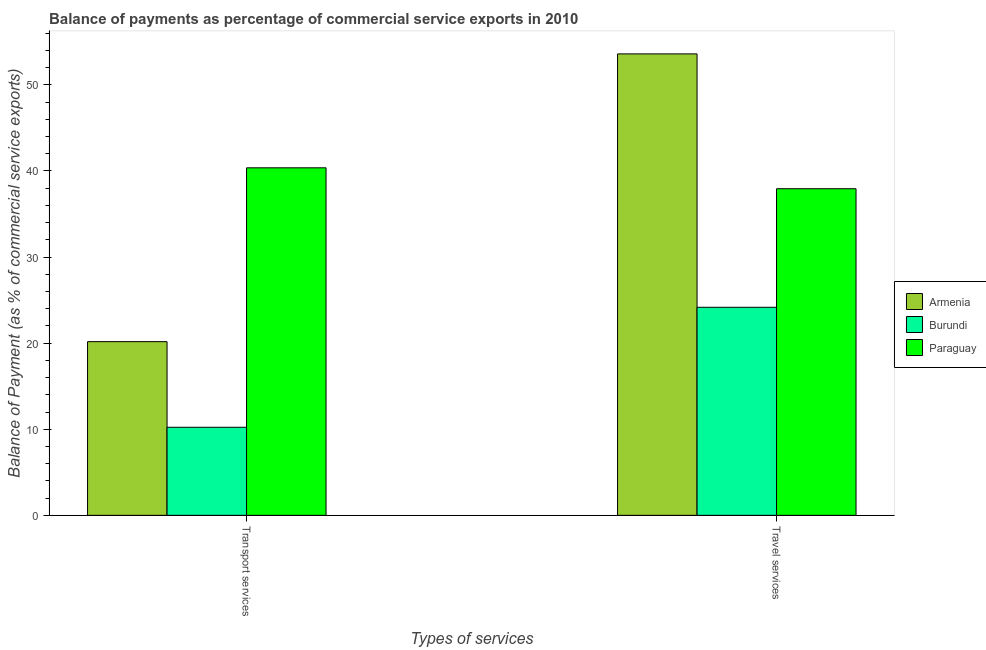How many groups of bars are there?
Your answer should be compact. 2. Are the number of bars per tick equal to the number of legend labels?
Give a very brief answer. Yes. What is the label of the 1st group of bars from the left?
Offer a terse response. Transport services. What is the balance of payments of travel services in Burundi?
Make the answer very short. 24.16. Across all countries, what is the maximum balance of payments of travel services?
Give a very brief answer. 53.59. Across all countries, what is the minimum balance of payments of travel services?
Give a very brief answer. 24.16. In which country was the balance of payments of transport services maximum?
Keep it short and to the point. Paraguay. In which country was the balance of payments of transport services minimum?
Your response must be concise. Burundi. What is the total balance of payments of travel services in the graph?
Offer a terse response. 115.68. What is the difference between the balance of payments of travel services in Paraguay and that in Armenia?
Your answer should be compact. -15.66. What is the difference between the balance of payments of travel services in Armenia and the balance of payments of transport services in Burundi?
Offer a terse response. 43.36. What is the average balance of payments of transport services per country?
Ensure brevity in your answer.  23.58. What is the difference between the balance of payments of travel services and balance of payments of transport services in Paraguay?
Provide a succinct answer. -2.43. What is the ratio of the balance of payments of transport services in Burundi to that in Armenia?
Your answer should be compact. 0.51. In how many countries, is the balance of payments of transport services greater than the average balance of payments of transport services taken over all countries?
Your response must be concise. 1. What does the 2nd bar from the left in Transport services represents?
Offer a very short reply. Burundi. What does the 1st bar from the right in Travel services represents?
Provide a succinct answer. Paraguay. Are all the bars in the graph horizontal?
Ensure brevity in your answer.  No. How many countries are there in the graph?
Keep it short and to the point. 3. Does the graph contain any zero values?
Keep it short and to the point. No. How many legend labels are there?
Offer a terse response. 3. What is the title of the graph?
Give a very brief answer. Balance of payments as percentage of commercial service exports in 2010. Does "Mongolia" appear as one of the legend labels in the graph?
Offer a terse response. No. What is the label or title of the X-axis?
Keep it short and to the point. Types of services. What is the label or title of the Y-axis?
Provide a succinct answer. Balance of Payment (as % of commercial service exports). What is the Balance of Payment (as % of commercial service exports) in Armenia in Transport services?
Ensure brevity in your answer.  20.17. What is the Balance of Payment (as % of commercial service exports) of Burundi in Transport services?
Keep it short and to the point. 10.23. What is the Balance of Payment (as % of commercial service exports) of Paraguay in Transport services?
Your answer should be compact. 40.36. What is the Balance of Payment (as % of commercial service exports) in Armenia in Travel services?
Ensure brevity in your answer.  53.59. What is the Balance of Payment (as % of commercial service exports) of Burundi in Travel services?
Keep it short and to the point. 24.16. What is the Balance of Payment (as % of commercial service exports) in Paraguay in Travel services?
Ensure brevity in your answer.  37.93. Across all Types of services, what is the maximum Balance of Payment (as % of commercial service exports) of Armenia?
Your response must be concise. 53.59. Across all Types of services, what is the maximum Balance of Payment (as % of commercial service exports) in Burundi?
Offer a very short reply. 24.16. Across all Types of services, what is the maximum Balance of Payment (as % of commercial service exports) of Paraguay?
Provide a short and direct response. 40.36. Across all Types of services, what is the minimum Balance of Payment (as % of commercial service exports) in Armenia?
Offer a very short reply. 20.17. Across all Types of services, what is the minimum Balance of Payment (as % of commercial service exports) in Burundi?
Make the answer very short. 10.23. Across all Types of services, what is the minimum Balance of Payment (as % of commercial service exports) of Paraguay?
Make the answer very short. 37.93. What is the total Balance of Payment (as % of commercial service exports) in Armenia in the graph?
Your answer should be compact. 73.76. What is the total Balance of Payment (as % of commercial service exports) of Burundi in the graph?
Your answer should be compact. 34.39. What is the total Balance of Payment (as % of commercial service exports) of Paraguay in the graph?
Provide a short and direct response. 78.29. What is the difference between the Balance of Payment (as % of commercial service exports) of Armenia in Transport services and that in Travel services?
Provide a succinct answer. -33.42. What is the difference between the Balance of Payment (as % of commercial service exports) in Burundi in Transport services and that in Travel services?
Ensure brevity in your answer.  -13.93. What is the difference between the Balance of Payment (as % of commercial service exports) in Paraguay in Transport services and that in Travel services?
Offer a terse response. 2.43. What is the difference between the Balance of Payment (as % of commercial service exports) of Armenia in Transport services and the Balance of Payment (as % of commercial service exports) of Burundi in Travel services?
Give a very brief answer. -3.99. What is the difference between the Balance of Payment (as % of commercial service exports) in Armenia in Transport services and the Balance of Payment (as % of commercial service exports) in Paraguay in Travel services?
Make the answer very short. -17.76. What is the difference between the Balance of Payment (as % of commercial service exports) of Burundi in Transport services and the Balance of Payment (as % of commercial service exports) of Paraguay in Travel services?
Provide a short and direct response. -27.7. What is the average Balance of Payment (as % of commercial service exports) of Armenia per Types of services?
Offer a terse response. 36.88. What is the average Balance of Payment (as % of commercial service exports) of Burundi per Types of services?
Your answer should be very brief. 17.19. What is the average Balance of Payment (as % of commercial service exports) in Paraguay per Types of services?
Give a very brief answer. 39.14. What is the difference between the Balance of Payment (as % of commercial service exports) of Armenia and Balance of Payment (as % of commercial service exports) of Burundi in Transport services?
Your response must be concise. 9.94. What is the difference between the Balance of Payment (as % of commercial service exports) in Armenia and Balance of Payment (as % of commercial service exports) in Paraguay in Transport services?
Ensure brevity in your answer.  -20.19. What is the difference between the Balance of Payment (as % of commercial service exports) of Burundi and Balance of Payment (as % of commercial service exports) of Paraguay in Transport services?
Offer a very short reply. -30.13. What is the difference between the Balance of Payment (as % of commercial service exports) of Armenia and Balance of Payment (as % of commercial service exports) of Burundi in Travel services?
Your answer should be compact. 29.43. What is the difference between the Balance of Payment (as % of commercial service exports) of Armenia and Balance of Payment (as % of commercial service exports) of Paraguay in Travel services?
Provide a succinct answer. 15.66. What is the difference between the Balance of Payment (as % of commercial service exports) of Burundi and Balance of Payment (as % of commercial service exports) of Paraguay in Travel services?
Your answer should be compact. -13.77. What is the ratio of the Balance of Payment (as % of commercial service exports) in Armenia in Transport services to that in Travel services?
Ensure brevity in your answer.  0.38. What is the ratio of the Balance of Payment (as % of commercial service exports) of Burundi in Transport services to that in Travel services?
Provide a succinct answer. 0.42. What is the ratio of the Balance of Payment (as % of commercial service exports) in Paraguay in Transport services to that in Travel services?
Your answer should be compact. 1.06. What is the difference between the highest and the second highest Balance of Payment (as % of commercial service exports) of Armenia?
Your response must be concise. 33.42. What is the difference between the highest and the second highest Balance of Payment (as % of commercial service exports) in Burundi?
Provide a short and direct response. 13.93. What is the difference between the highest and the second highest Balance of Payment (as % of commercial service exports) of Paraguay?
Ensure brevity in your answer.  2.43. What is the difference between the highest and the lowest Balance of Payment (as % of commercial service exports) in Armenia?
Your answer should be compact. 33.42. What is the difference between the highest and the lowest Balance of Payment (as % of commercial service exports) in Burundi?
Ensure brevity in your answer.  13.93. What is the difference between the highest and the lowest Balance of Payment (as % of commercial service exports) of Paraguay?
Give a very brief answer. 2.43. 